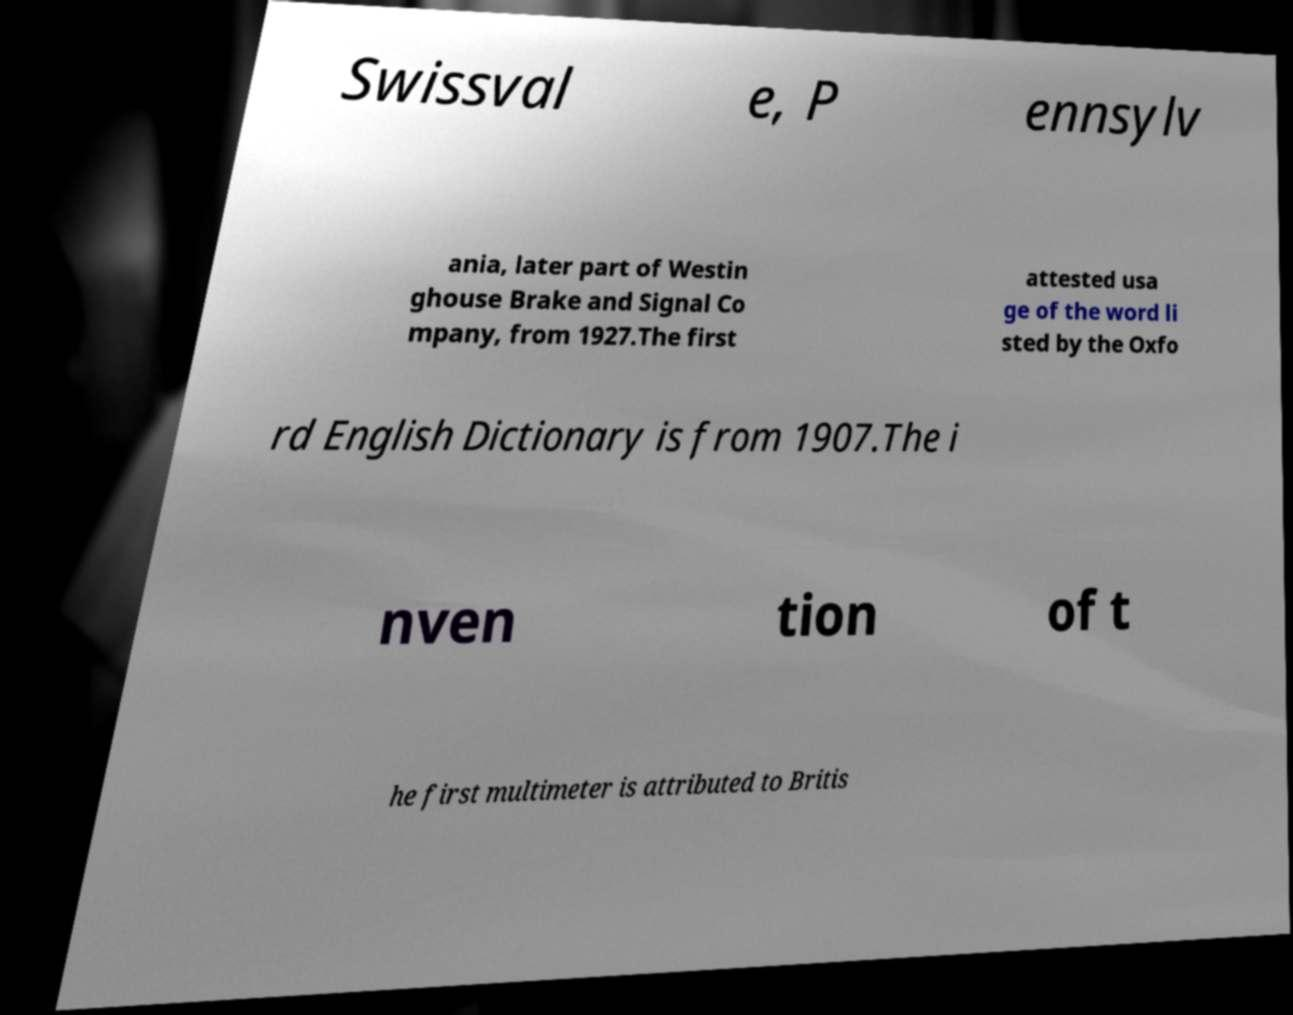I need the written content from this picture converted into text. Can you do that? Swissval e, P ennsylv ania, later part of Westin ghouse Brake and Signal Co mpany, from 1927.The first attested usa ge of the word li sted by the Oxfo rd English Dictionary is from 1907.The i nven tion of t he first multimeter is attributed to Britis 